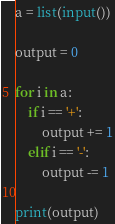Convert code to text. <code><loc_0><loc_0><loc_500><loc_500><_Python_>a = list(input())

output = 0

for i in a:
    if i == '+':
        output += 1
    elif i == '-':
        output -= 1

print(output)
</code> 